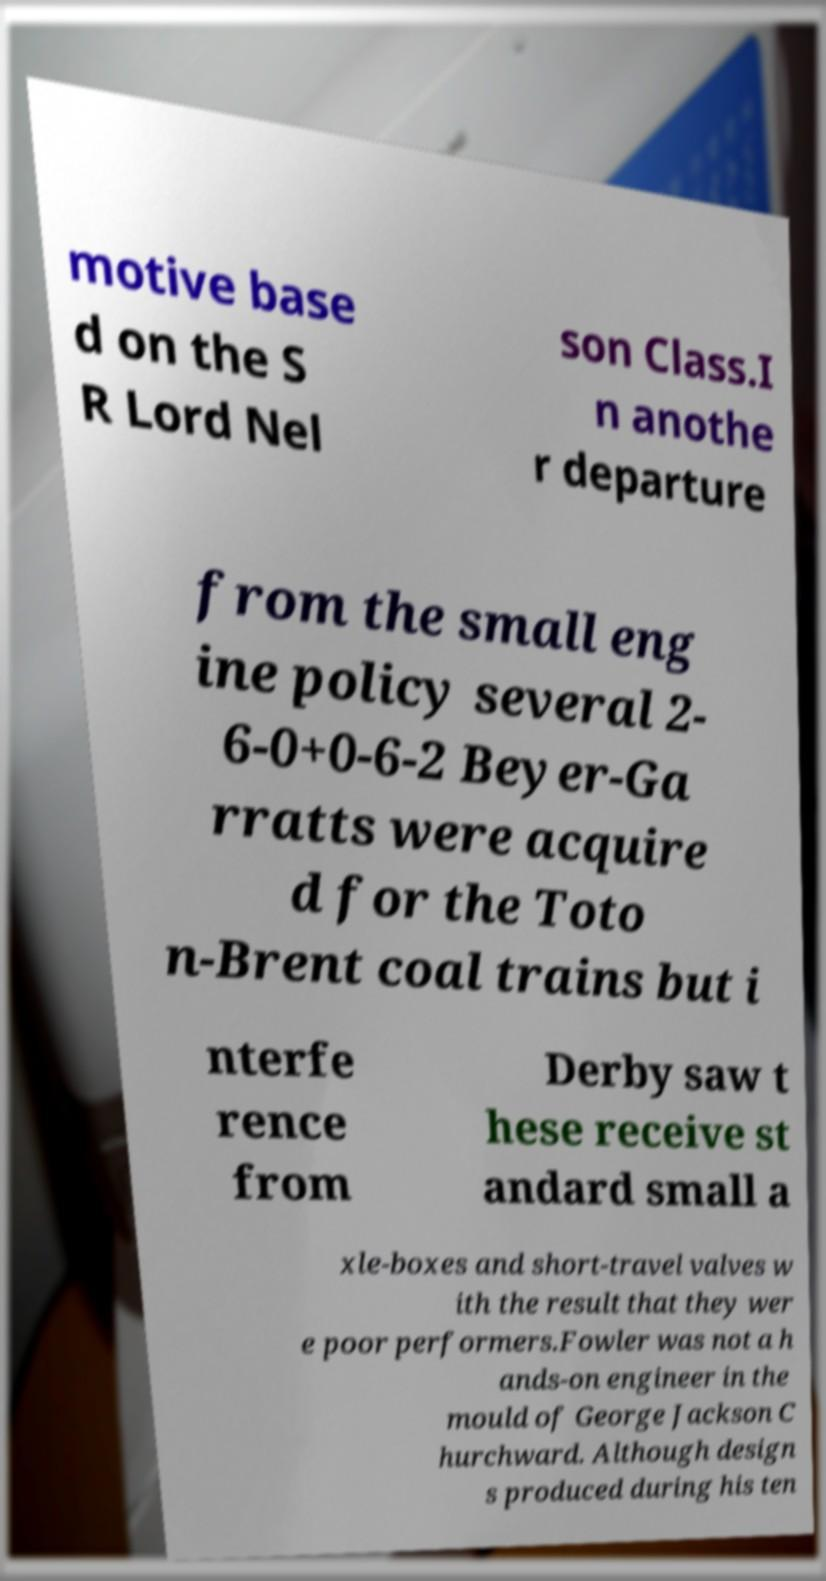Please identify and transcribe the text found in this image. motive base d on the S R Lord Nel son Class.I n anothe r departure from the small eng ine policy several 2- 6-0+0-6-2 Beyer-Ga rratts were acquire d for the Toto n-Brent coal trains but i nterfe rence from Derby saw t hese receive st andard small a xle-boxes and short-travel valves w ith the result that they wer e poor performers.Fowler was not a h ands-on engineer in the mould of George Jackson C hurchward. Although design s produced during his ten 